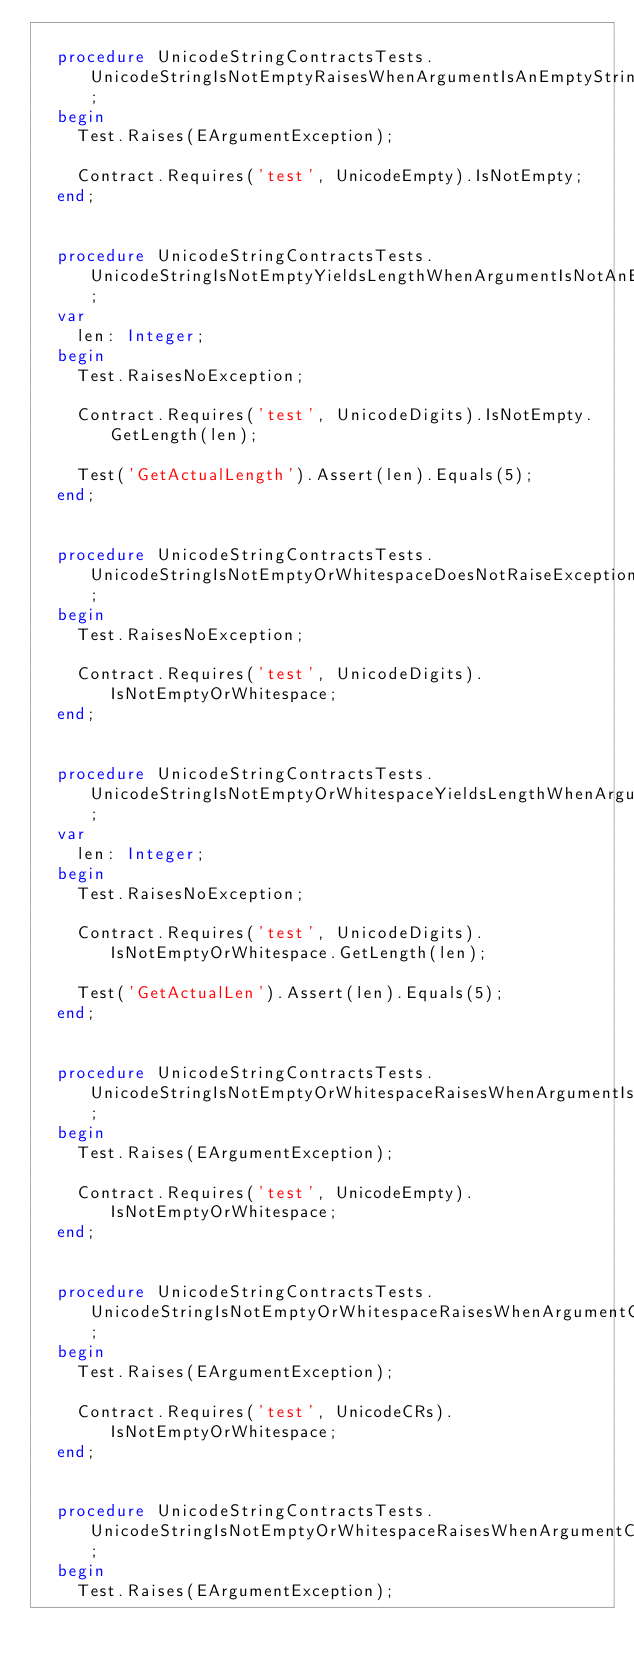<code> <loc_0><loc_0><loc_500><loc_500><_Pascal_>
  procedure UnicodeStringContractsTests.UnicodeStringIsNotEmptyRaisesWhenArgumentIsAnEmptyString;
  begin
    Test.Raises(EArgumentException);

    Contract.Requires('test', UnicodeEmpty).IsNotEmpty;
  end;


  procedure UnicodeStringContractsTests.UnicodeStringIsNotEmptyYieldsLengthWhenArgumentIsNotAnEmptyString;
  var
    len: Integer;
  begin
    Test.RaisesNoException;

    Contract.Requires('test', UnicodeDigits).IsNotEmpty.GetLength(len);

    Test('GetActualLength').Assert(len).Equals(5);
  end;


  procedure UnicodeStringContractsTests.UnicodeStringIsNotEmptyOrWhitespaceDoesNotRaiseExceptionWhenArgumentIsNotAnEmptyWhitespaceString;
  begin
    Test.RaisesNoException;

    Contract.Requires('test', UnicodeDigits).IsNotEmptyOrWhitespace;
  end;


  procedure UnicodeStringContractsTests.UnicodeStringIsNotEmptyOrWhitespaceYieldsLengthWhenArgumentIsNotAnEmptyWhitespaceString;
  var
    len: Integer;
  begin
    Test.RaisesNoException;

    Contract.Requires('test', UnicodeDigits).IsNotEmptyOrWhitespace.GetLength(len);

    Test('GetActualLen').Assert(len).Equals(5);
  end;


  procedure UnicodeStringContractsTests.UnicodeStringIsNotEmptyOrWhitespaceRaisesWhenArgumentIsAnEmptyString;
  begin
    Test.Raises(EArgumentException);

    Contract.Requires('test', UnicodeEmpty).IsNotEmptyOrWhitespace;
  end;


  procedure UnicodeStringContractsTests.UnicodeStringIsNotEmptyOrWhitespaceRaisesWhenArgumentContainsOnlyCarriageReturns;
  begin
    Test.Raises(EArgumentException);

    Contract.Requires('test', UnicodeCRs).IsNotEmptyOrWhitespace;
  end;


  procedure UnicodeStringContractsTests.UnicodeStringIsNotEmptyOrWhitespaceRaisesWhenArgumentContainsOnlyLineFeeds;
  begin
    Test.Raises(EArgumentException);
</code> 